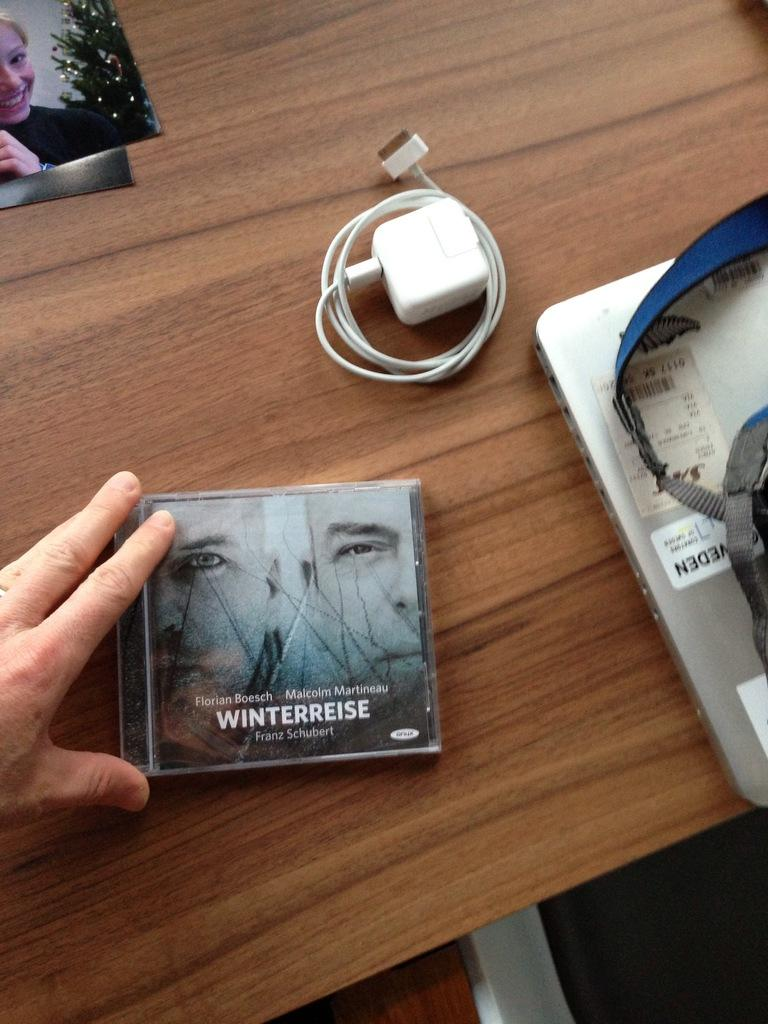Provide a one-sentence caption for the provided image. cd fronm winterreise and iphone charger on the table. 